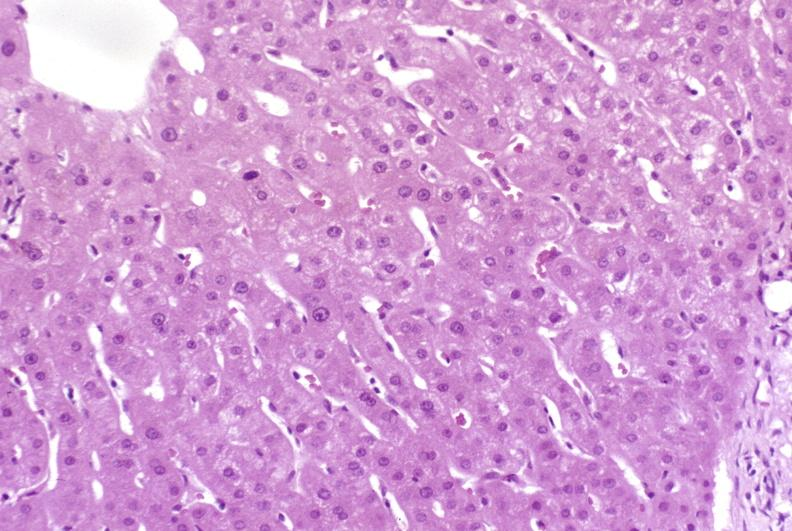what is present?
Answer the question using a single word or phrase. Liver 